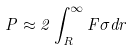<formula> <loc_0><loc_0><loc_500><loc_500>P \approx 2 \int _ { R } ^ { \infty } F \sigma d r</formula> 